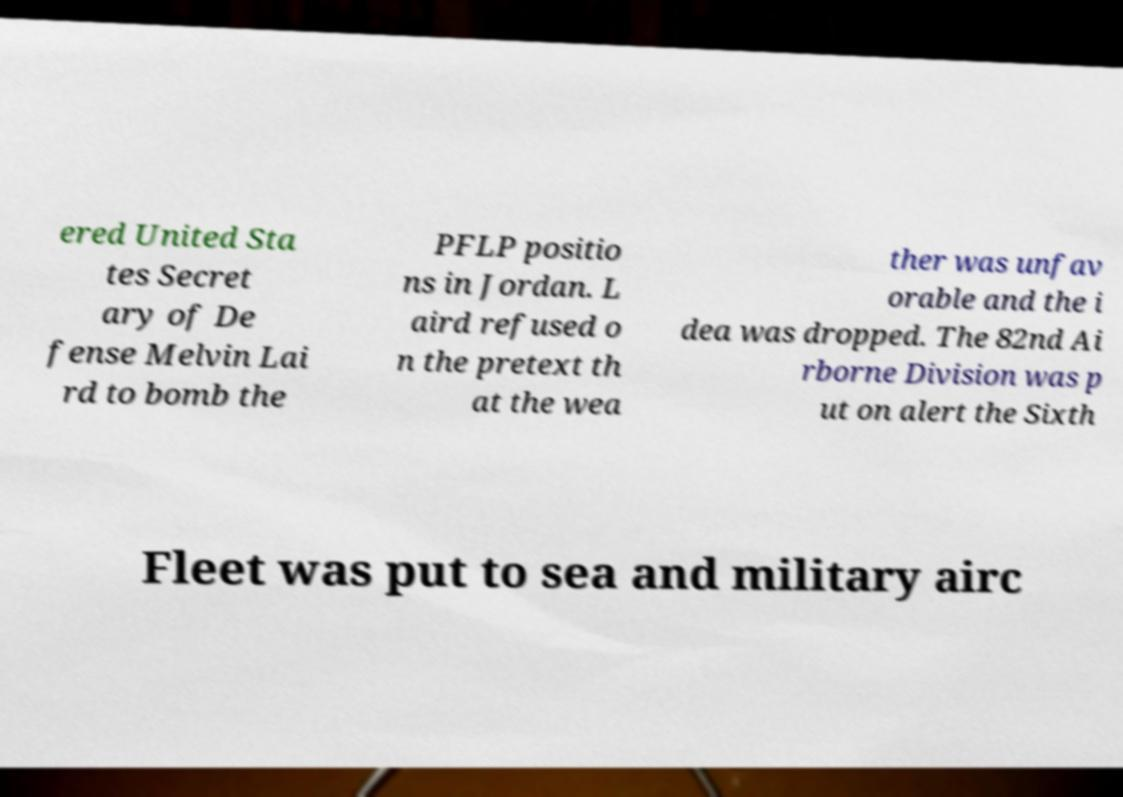I need the written content from this picture converted into text. Can you do that? ered United Sta tes Secret ary of De fense Melvin Lai rd to bomb the PFLP positio ns in Jordan. L aird refused o n the pretext th at the wea ther was unfav orable and the i dea was dropped. The 82nd Ai rborne Division was p ut on alert the Sixth Fleet was put to sea and military airc 